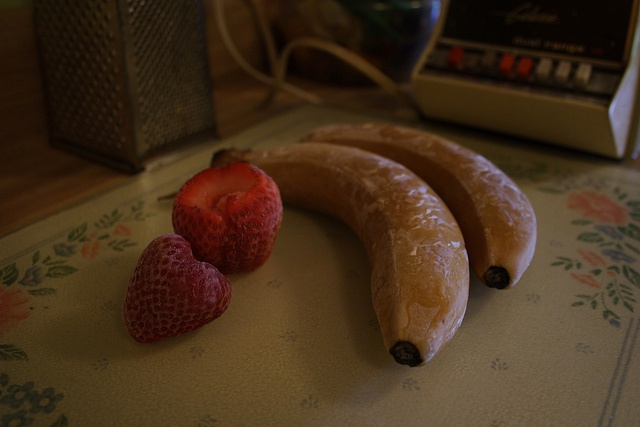Describe the objects in this image and their specific colors. I can see banana in black, maroon, and gray tones and banana in black, maroon, and gray tones in this image. 